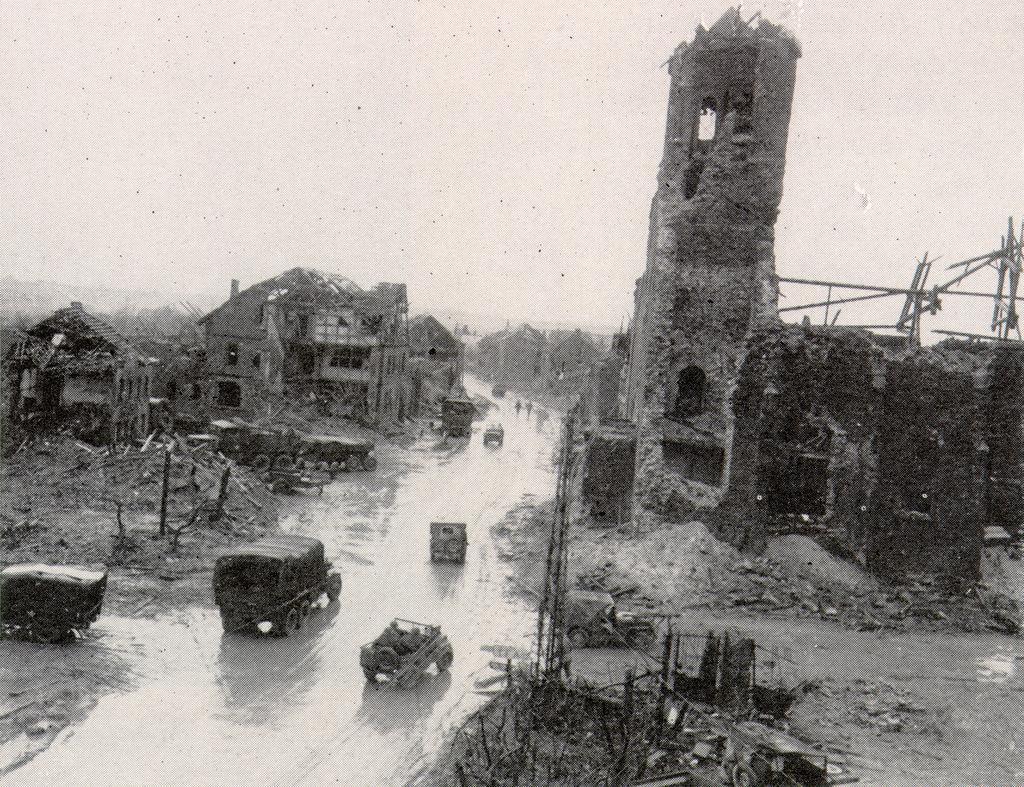How would you summarize this image in a sentence or two? In this image there are vehicles on the road and the buildings beside the road has been destroyed. 